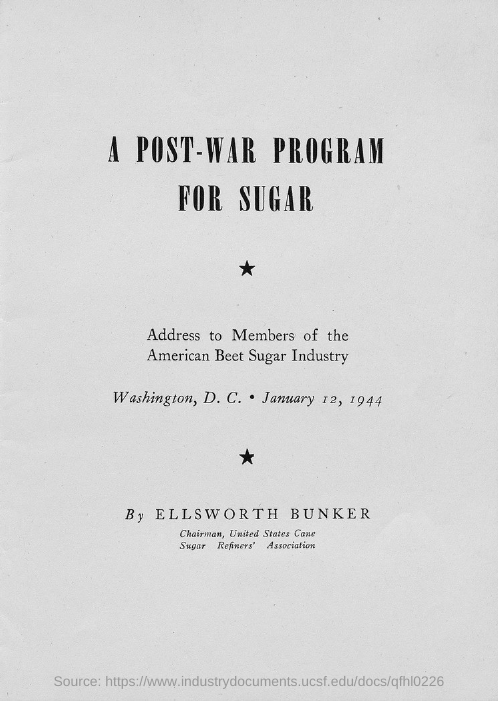Identify some key points in this picture. The title of the document is 'A POST-WAR PROGRAM FOR SUGAR.' 